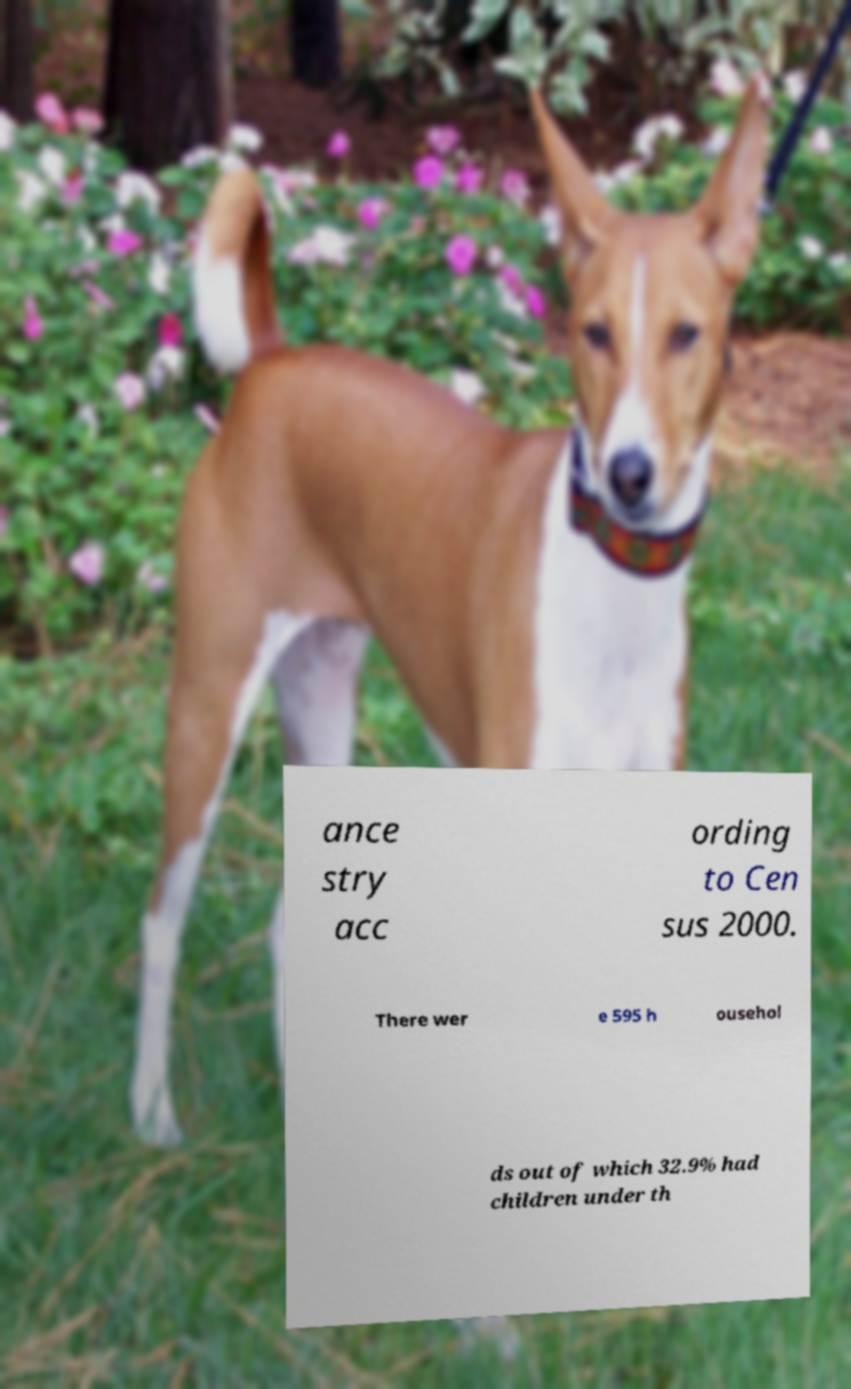Could you extract and type out the text from this image? ance stry acc ording to Cen sus 2000. There wer e 595 h ousehol ds out of which 32.9% had children under th 